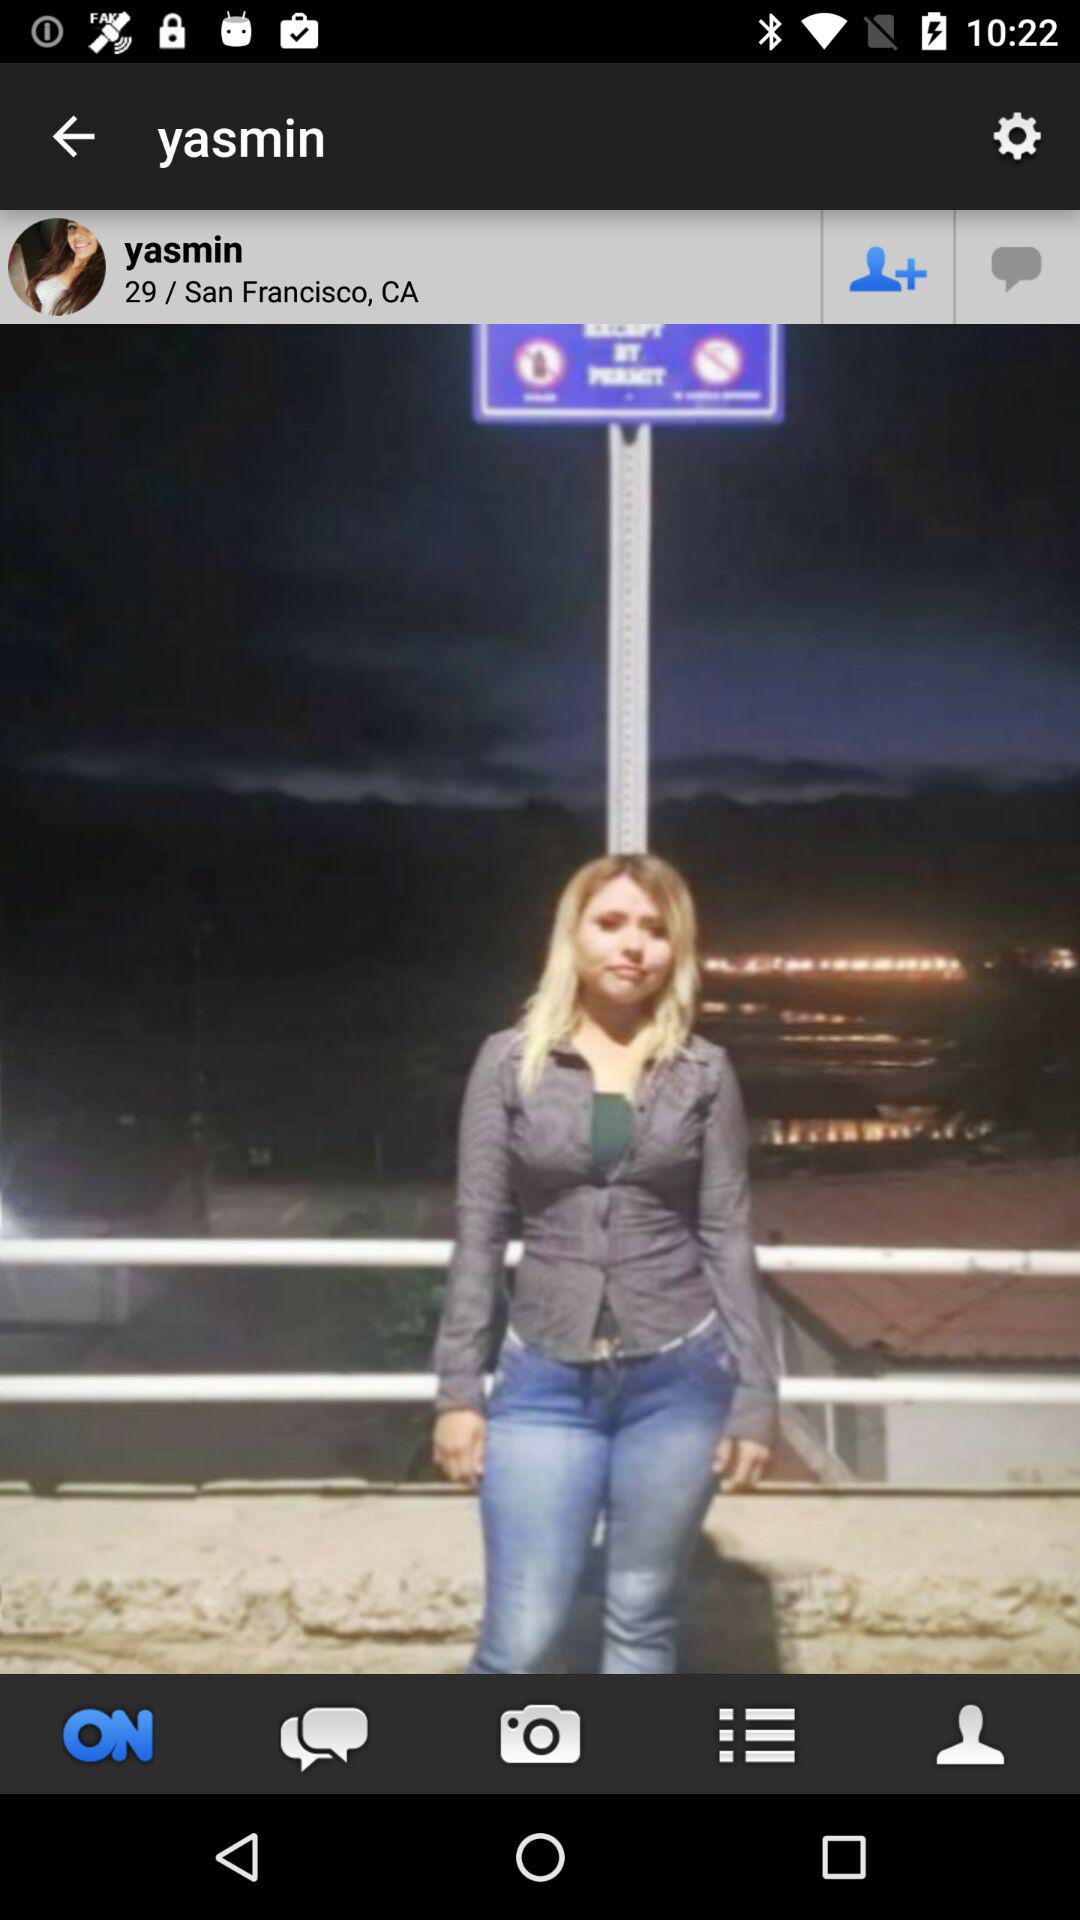What is the mentioned place? The mentioned place is San Francisco, CA. 